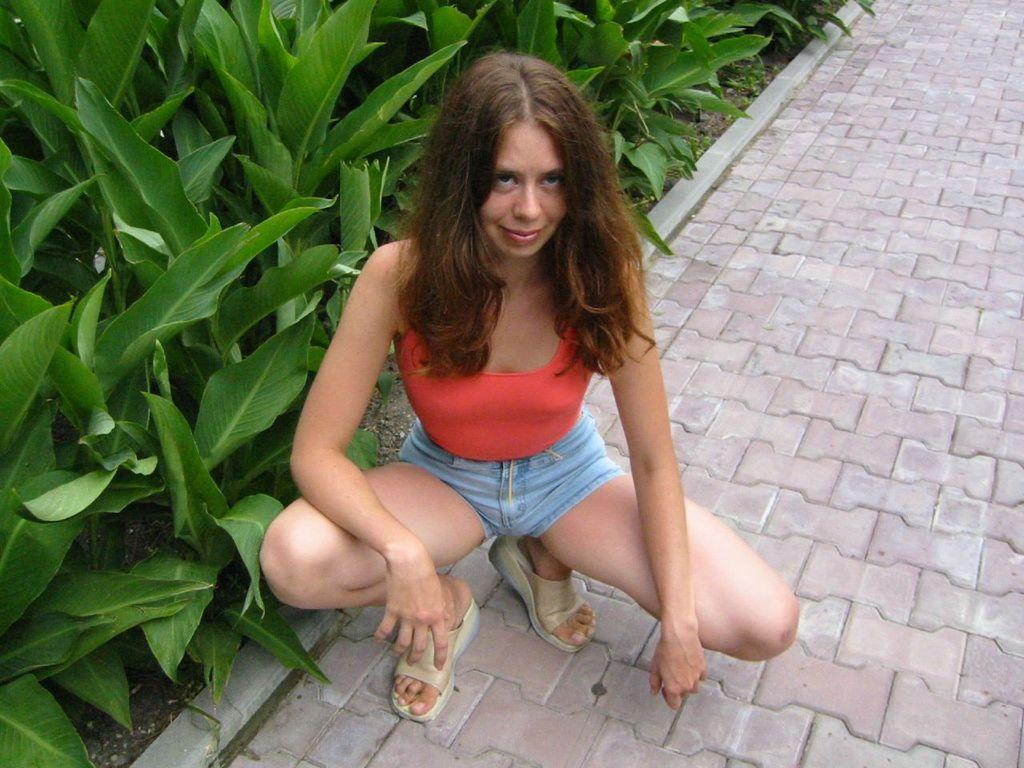Who is the main subject in the image? There is a woman in the image. What is the woman doing in the image? The woman is in a squat position on a path. What can be seen on the left side of the image? There are planets depicted on the ground on the left side of the image. Can you see any cows grazing near the seashore in the image? There is no seashore or cows present in the image; it features a woman in a squat position on a path with planets depicted on the ground. 